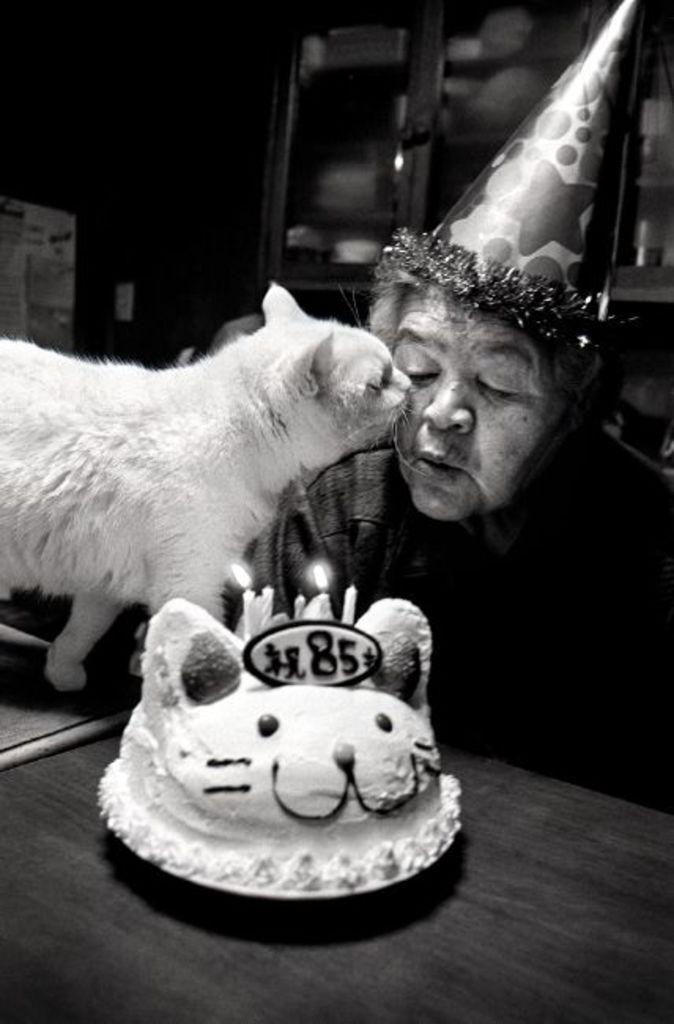Describe this image in one or two sentences. In this picture there is a lady who is sitting at the right side of the image and there is a table in front of them on which there is a cake and there is a cat at the left side of the image it is kissing the lady. 